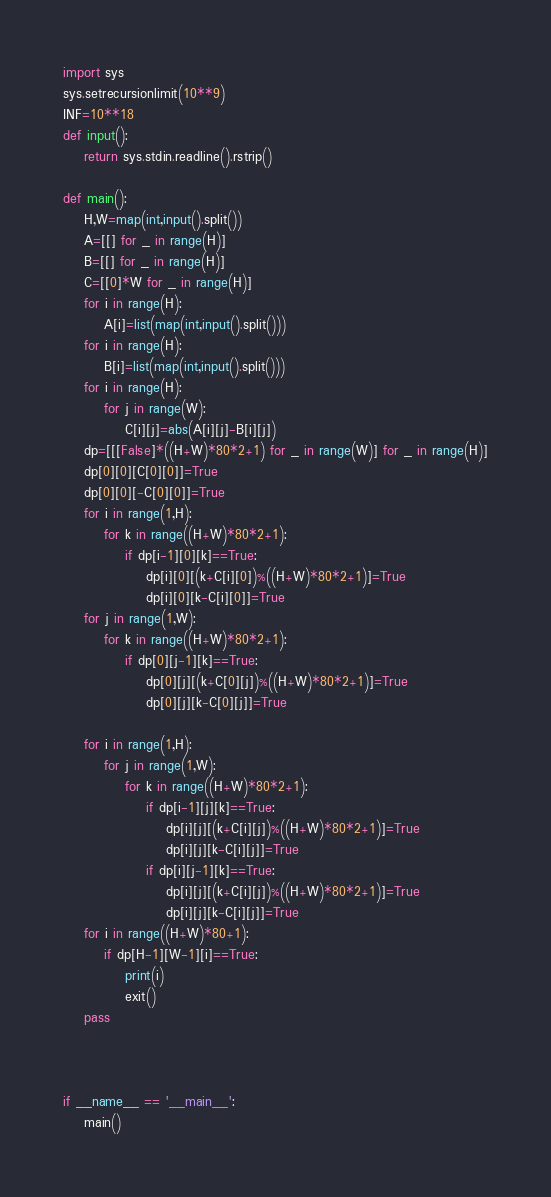<code> <loc_0><loc_0><loc_500><loc_500><_Python_>import sys
sys.setrecursionlimit(10**9)
INF=10**18
def input():
    return sys.stdin.readline().rstrip()

def main():
    H,W=map(int,input().split())
    A=[[] for _ in range(H)]
    B=[[] for _ in range(H)]
    C=[[0]*W for _ in range(H)]
    for i in range(H):
        A[i]=list(map(int,input().split()))
    for i in range(H):
        B[i]=list(map(int,input().split()))
    for i in range(H):
        for j in range(W):
            C[i][j]=abs(A[i][j]-B[i][j])
    dp=[[[False]*((H+W)*80*2+1) for _ in range(W)] for _ in range(H)]
    dp[0][0][C[0][0]]=True
    dp[0][0][-C[0][0]]=True
    for i in range(1,H):
        for k in range((H+W)*80*2+1):
            if dp[i-1][0][k]==True:
                dp[i][0][(k+C[i][0])%((H+W)*80*2+1)]=True
                dp[i][0][k-C[i][0]]=True
    for j in range(1,W):
        for k in range((H+W)*80*2+1):
            if dp[0][j-1][k]==True:
                dp[0][j][(k+C[0][j])%((H+W)*80*2+1)]=True
                dp[0][j][k-C[0][j]]=True
    
    for i in range(1,H):
        for j in range(1,W):
            for k in range((H+W)*80*2+1):
                if dp[i-1][j][k]==True:
                    dp[i][j][(k+C[i][j])%((H+W)*80*2+1)]=True
                    dp[i][j][k-C[i][j]]=True
                if dp[i][j-1][k]==True:
                    dp[i][j][(k+C[i][j])%((H+W)*80*2+1)]=True
                    dp[i][j][k-C[i][j]]=True
    for i in range((H+W)*80+1):
        if dp[H-1][W-1][i]==True:
            print(i)
            exit()
    pass
    
    

if __name__ == '__main__':
    main()
</code> 